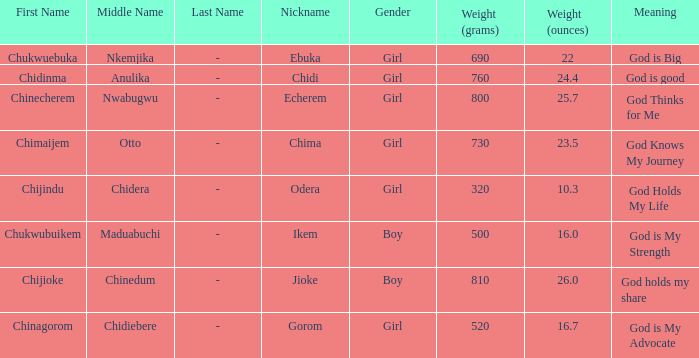What is the alias of the baby who was born weighing 730g (2 Chima. 